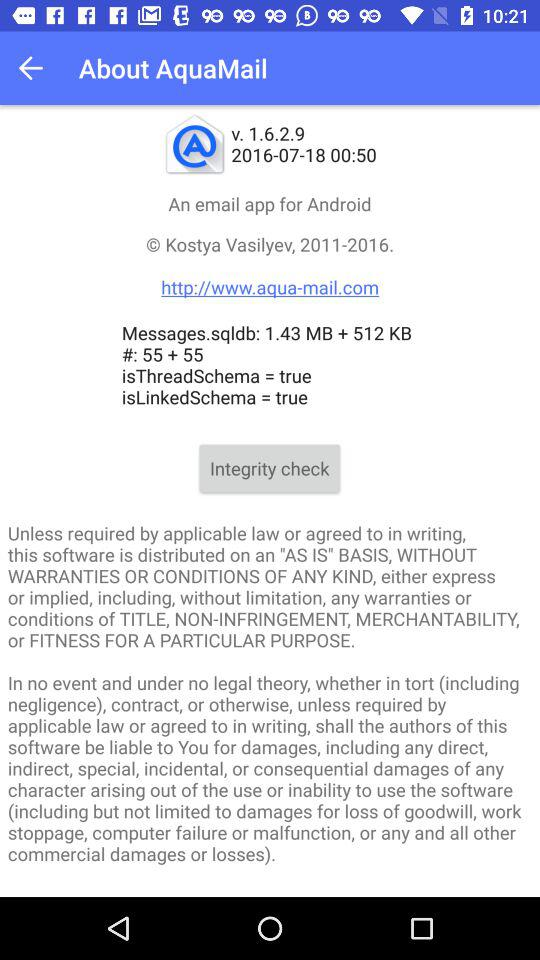What is the version of the application? The version of the application is v. 1.6.2.9. 